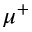<formula> <loc_0><loc_0><loc_500><loc_500>\mu ^ { + }</formula> 